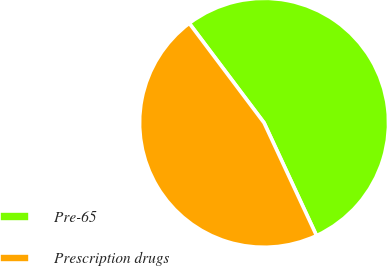Convert chart to OTSL. <chart><loc_0><loc_0><loc_500><loc_500><pie_chart><fcel>Pre-65<fcel>Prescription drugs<nl><fcel>53.33%<fcel>46.67%<nl></chart> 